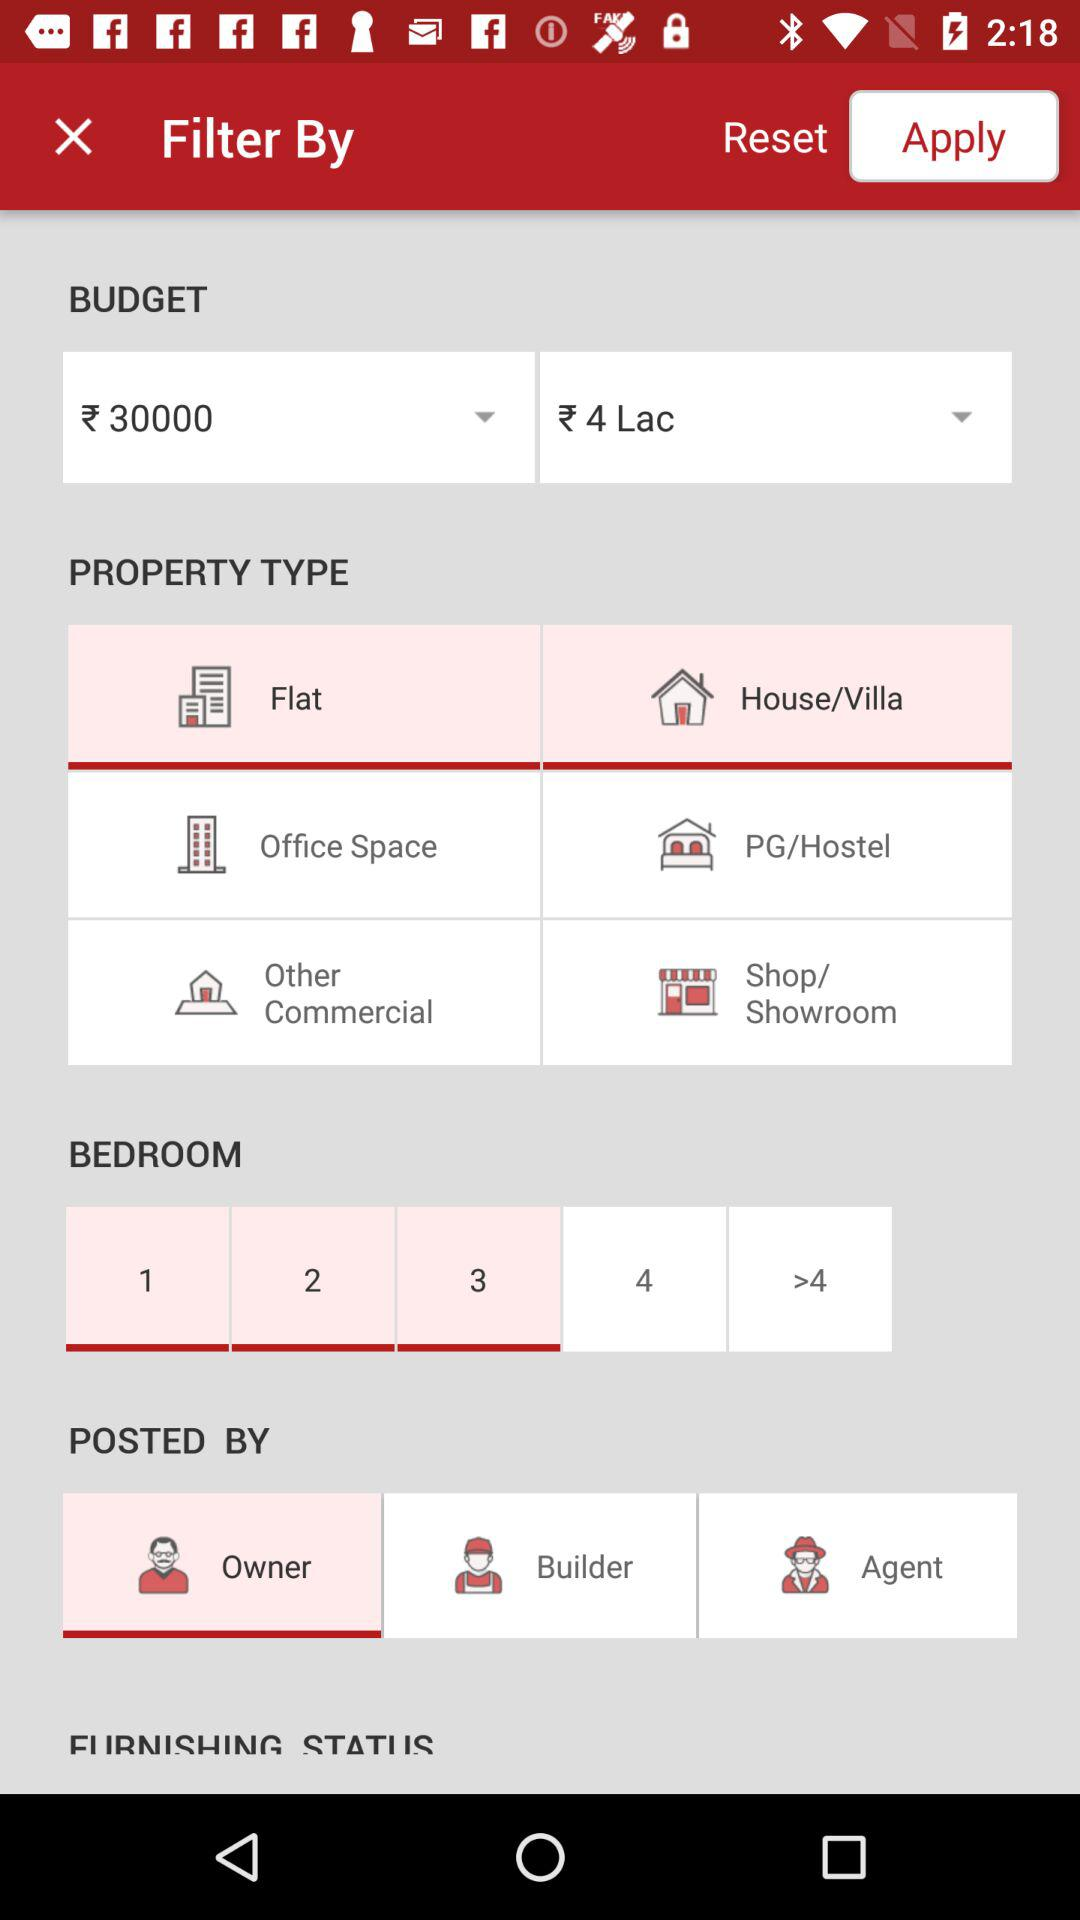Which property type has been selected? The selected property types are "Flat" and "House/Villa". 